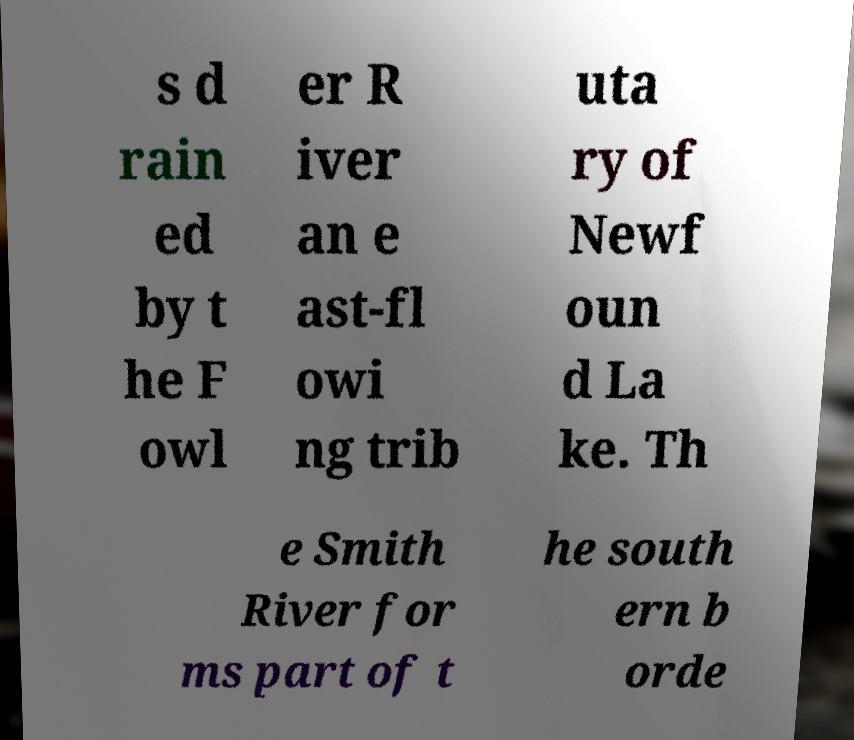Please read and relay the text visible in this image. What does it say? s d rain ed by t he F owl er R iver an e ast-fl owi ng trib uta ry of Newf oun d La ke. Th e Smith River for ms part of t he south ern b orde 